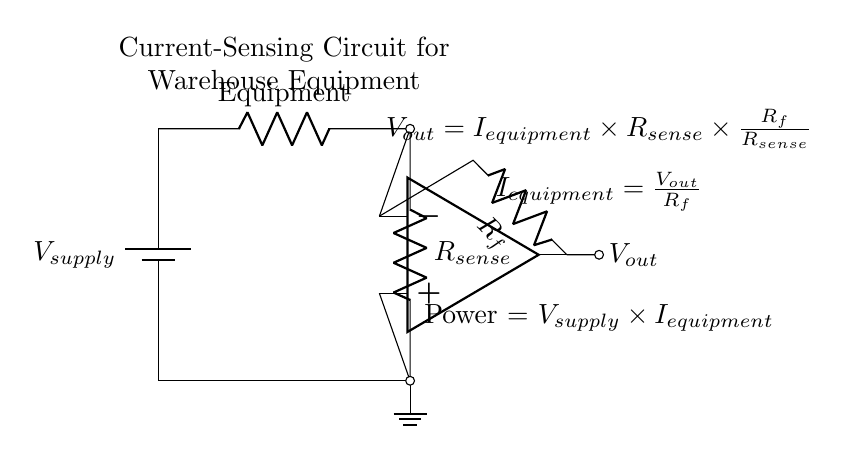What is the purpose of the current sensing resistor? The current sensing resistor, labeled as R_sense, is used to measure the current flowing through the equipment by creating a voltage drop proportional to the current.
Answer: Measure current What is the output voltage formula in this circuit? The formula for output voltage is given as V_out equals I_equipment times R_sense times R_f over R_sense. This represents the relationship between output voltage, input current, and feedback resistor value.
Answer: V_out = I_equipment * R_sense * (R_f / R_sense) What component is used to amplify the voltage? The component used for amplification is the operational amplifier, indicated in the circuit by the op amp symbol. It increases the voltage signal for further processing.
Answer: Operational amplifier What defines the current through the warehouse equipment? The current through the warehouse equipment is defined by the voltage supplied multiplied by the load resistance, as indicated by the formula for power. The relationship establishes how the equipment consumes power based on the supply voltage and its characteristics.
Answer: I_equipment = V_supply / Equipment What is the role of the feedback resistor R_f? The feedback resistor R_f shapes the gain of the operational amplifier, and its value directly influences the output voltage in relation to the sensed current, thus affecting the circuit's sensitivity.
Answer: Amplifies signal What happens to V_out if R_f is increased? If R_f is increased, V_out will also increase proportionally since V_out is directly influenced by R_f in the output voltage formula, effectively amplifying the observed current's effect.
Answer: V_out increases What type of circuit is this? This is an analog current-sensing circuit, specifically designed for monitoring power consumption in warehouse equipment by measuring the current flowing through it.
Answer: Analog current-sensing circuit 